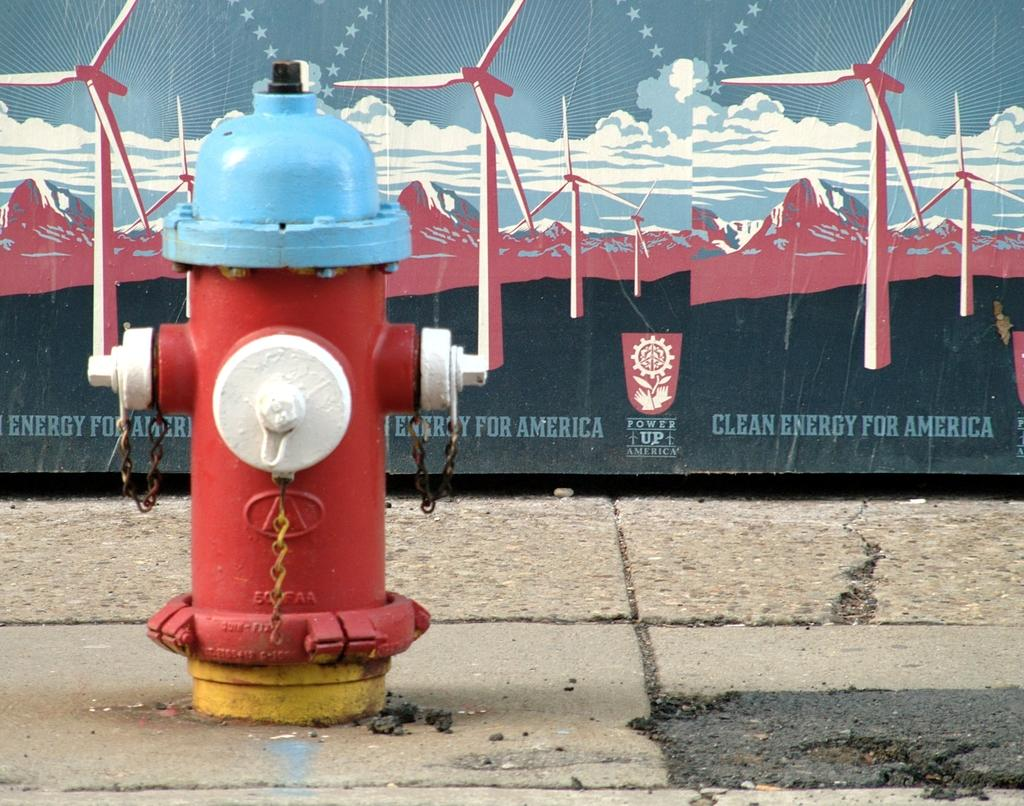What object is the main focus of the image? There is a fire hydrant in the image. What can be seen in the background of the image? There is a board with a picture and text in the background of the image. How many elbows can be seen on the fire hydrant in the image? There are no elbows present on the fire hydrant in the image, as it is a stationary object. 